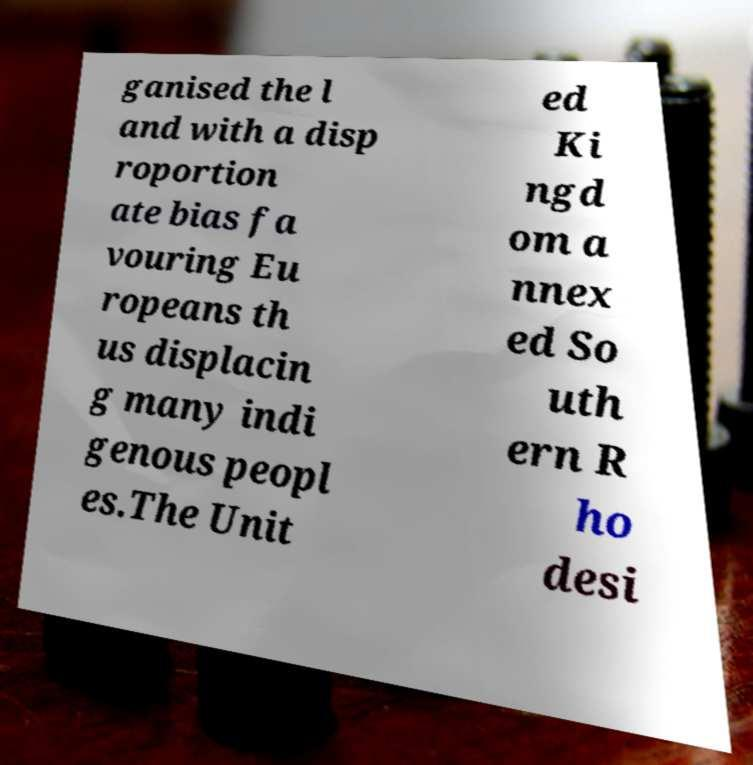Please read and relay the text visible in this image. What does it say? ganised the l and with a disp roportion ate bias fa vouring Eu ropeans th us displacin g many indi genous peopl es.The Unit ed Ki ngd om a nnex ed So uth ern R ho desi 